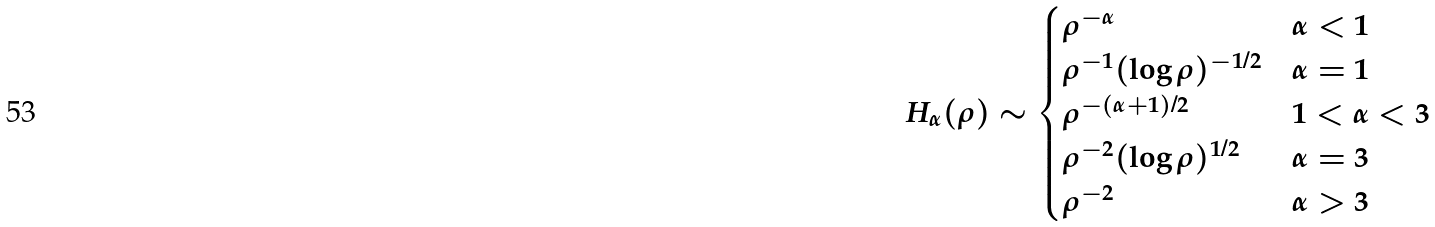Convert formula to latex. <formula><loc_0><loc_0><loc_500><loc_500>H _ { \alpha } ( \rho ) \sim \begin{cases} \rho ^ { - \alpha } & \alpha < 1 \\ \rho ^ { - 1 } ( \log \rho ) ^ { - 1 / 2 } & \alpha = 1 \\ \rho ^ { - ( \alpha + 1 ) / 2 } & 1 < \alpha < 3 \\ \rho ^ { - 2 } ( \log \rho ) ^ { 1 / 2 } & \alpha = 3 \\ \rho ^ { - 2 } & \alpha > 3 \end{cases}</formula> 